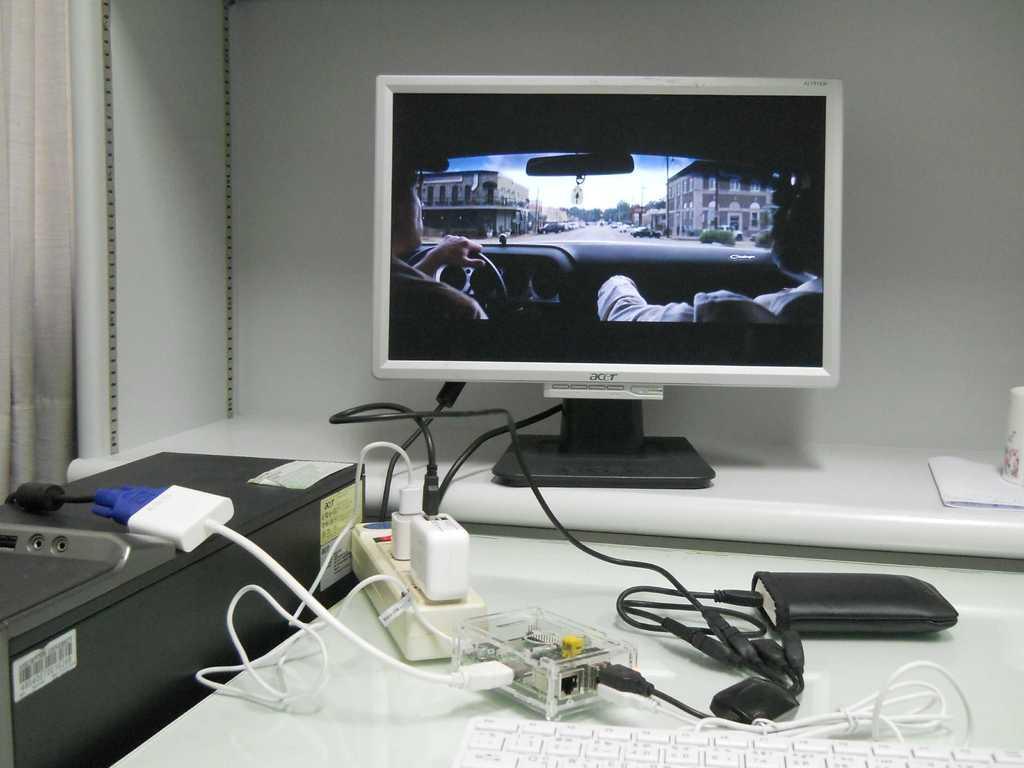Please provide a concise description of this image. This image consists of a monitor. In the front, there are chargers and CPUs along with a power bank and keyboard. In the background, there is a wall. To the left, there is a curtain. 